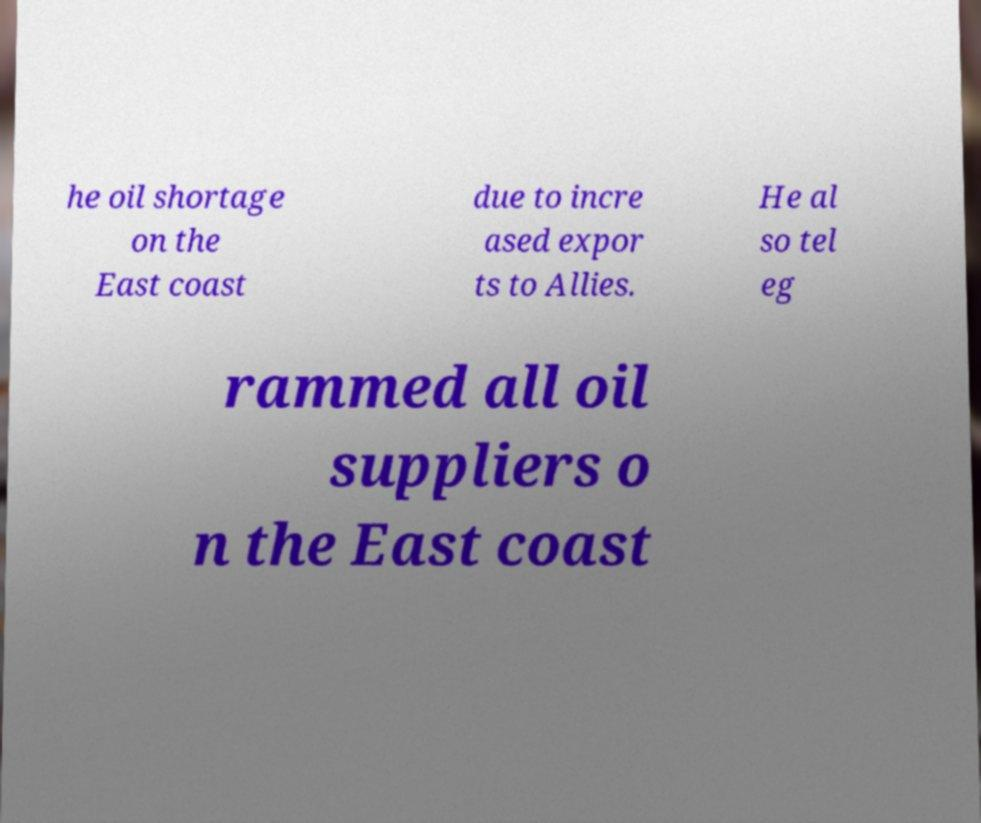What messages or text are displayed in this image? I need them in a readable, typed format. he oil shortage on the East coast due to incre ased expor ts to Allies. He al so tel eg rammed all oil suppliers o n the East coast 